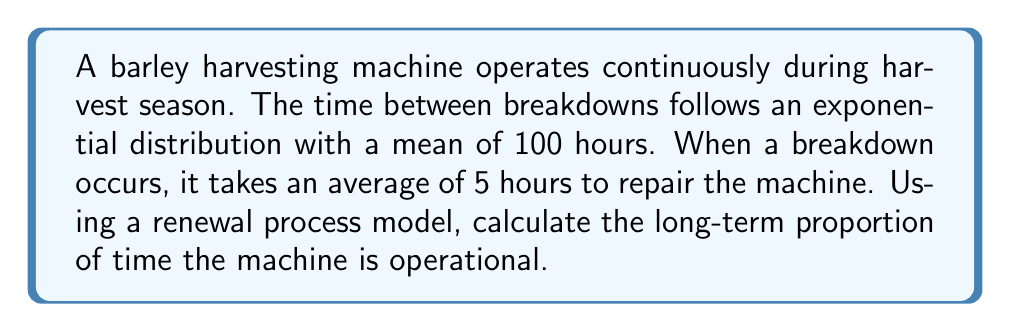Can you solve this math problem? Let's approach this step-by-step using renewal process theory:

1) First, we need to identify the components of our renewal process:
   - $X_i$: Time between breakdowns (exponentially distributed with mean 100 hours)
   - $Y_i$: Repair time (average 5 hours)

2) In a renewal process, we're interested in the long-term behavior. The key concept here is the renewal function $m(t)$, which represents the expected number of renewals up to time $t$.

3) For our problem, we need to calculate the availability of the machine, which is the proportion of time it's operational in the long run.

4) The availability $A$ is given by the formula:

   $$A = \frac{E[X]}{E[X] + E[Y]}$$

   where $E[X]$ is the expected time between breakdowns and $E[Y]$ is the expected repair time.

5) We're given:
   $E[X] = 100$ hours (mean of exponential distribution)
   $E[Y] = 5$ hours (average repair time)

6) Substituting these values into our availability formula:

   $$A = \frac{100}{100 + 5} = \frac{100}{105}$$

7) Simplifying:

   $$A = \frac{20}{21} \approx 0.9524$$

Therefore, in the long run, the machine is operational approximately 95.24% of the time.
Answer: $\frac{20}{21}$ or approximately 0.9524 